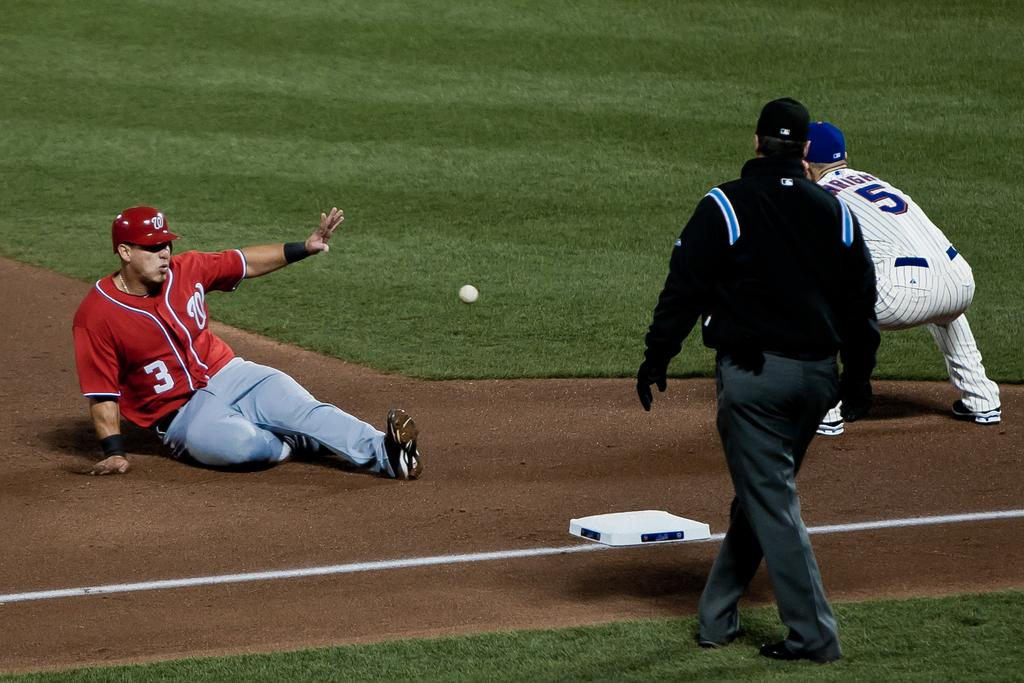<image>
Relay a brief, clear account of the picture shown. Baseball player #3 sliding into first base while #5 is trying to tag him out. 